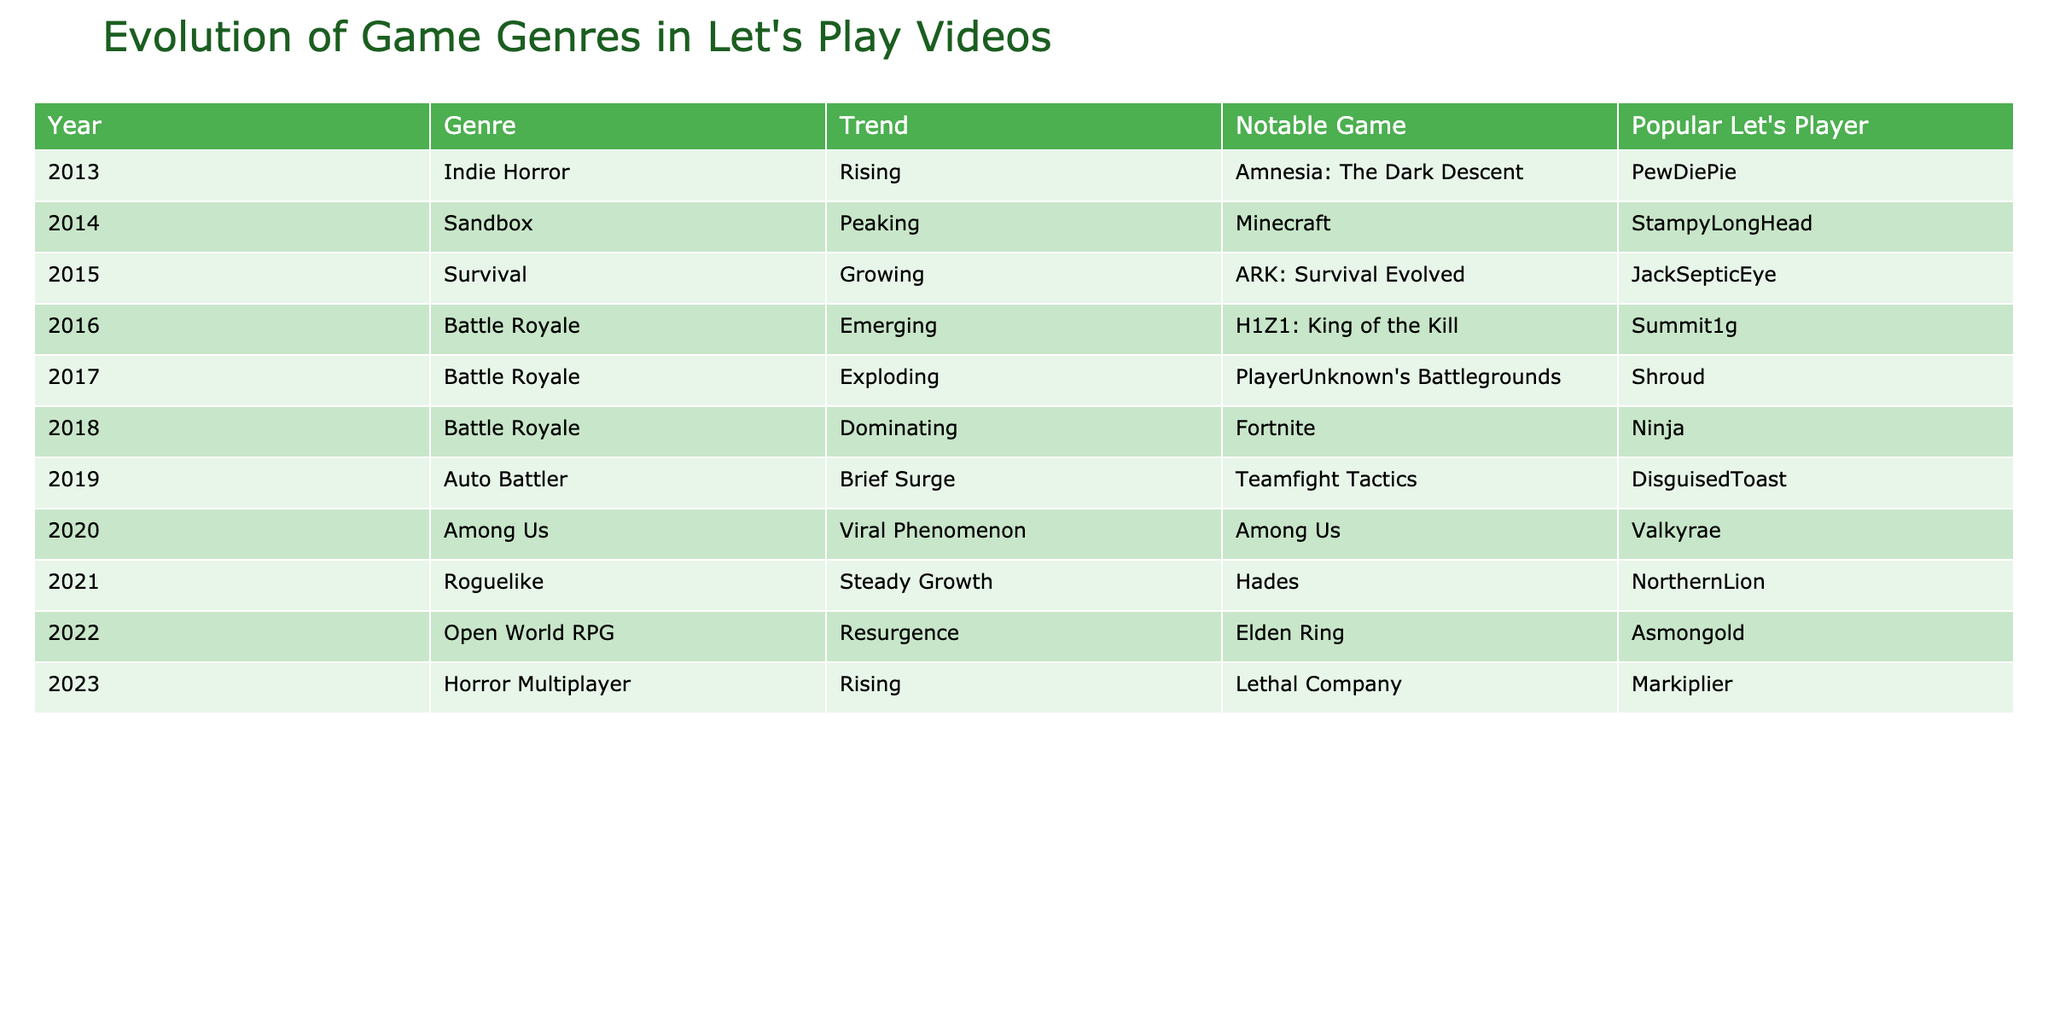What genre was featured in the Let's Play videos of 2016? According to the table, the genre for 2016 is "Battle Royale." You can find this directly in the row corresponding to that year.
Answer: Battle Royale Which notable game was associated with the Battle Royale genre in 2017? The notable game for the Battle Royale genre in 2017, as per the table, is "PlayerUnknown's Battlegrounds," shown in the same row.
Answer: PlayerUnknown's Battlegrounds How many game genres had the trend 'Rising' throughout the decade? The table lists three genres with the 'Rising' trend: Indie Horror in 2013, Horror Multiplayer in 2023, and Among Us in 2020. Thus, the total is three genres.
Answer: 3 Did the Survival genre experience a decline after 2015? The table shows that the Survival genre was growing in 2015 and was not listed again in subsequent years, suggesting it did not gain notable traction afterward. Therefore, it's reasonable to conclude there was a decline.
Answer: Yes Which Let's Player was associated with the viral phenomenon of Among Us in 2020? The table lists "Valkyrae" as the popular Let's Player for the game Among Us, identified under the respective year in the data.
Answer: Valkyrae What is the trend of the Open World RPG genre in 2022 compared to other years? The Open World RPG genre in 2022 is categorized as "Resurgence." To understand this trend, you can look at previous years and observe that genres like Battle Royale were dominant before. The resurgence indicates a revival compared to the growing or peaking trends of earlier years.
Answer: Resurgence Which year had the highest number of notable games listed and what was the game? The year with the highest number of notable games is 2018, with "Fortnite" listed under the Battle Royale genre, indicating it's a significant moment.
Answer: Fortnite What was the trend for the Auto Battler genre in 2019? The table states that the trend for the Auto Battler genre in 2019 was a "Brief Surge," reflecting a short-lived popularity in that year.
Answer: Brief Surge How does the popularity of genres change from 2013 to 2023 based on the trends displayed? By examining the table, you can observe a shift from Indie Horror in 2013, which was rising, to genres like Battle Royale dominating in 2018 and then a shift to genres like Horror Multiplayer in 2023 showing a new rising trend. This suggests a dynamic evolution of gaming preferences over the decade.
Answer: Varied trends over the years How many genres peaked between 2014 and 2020? In the specified range, based on the table, only Sandbox (2014) and Among Us (2020) are labeled with peak trends, thus it totals to two genres.
Answer: 2 